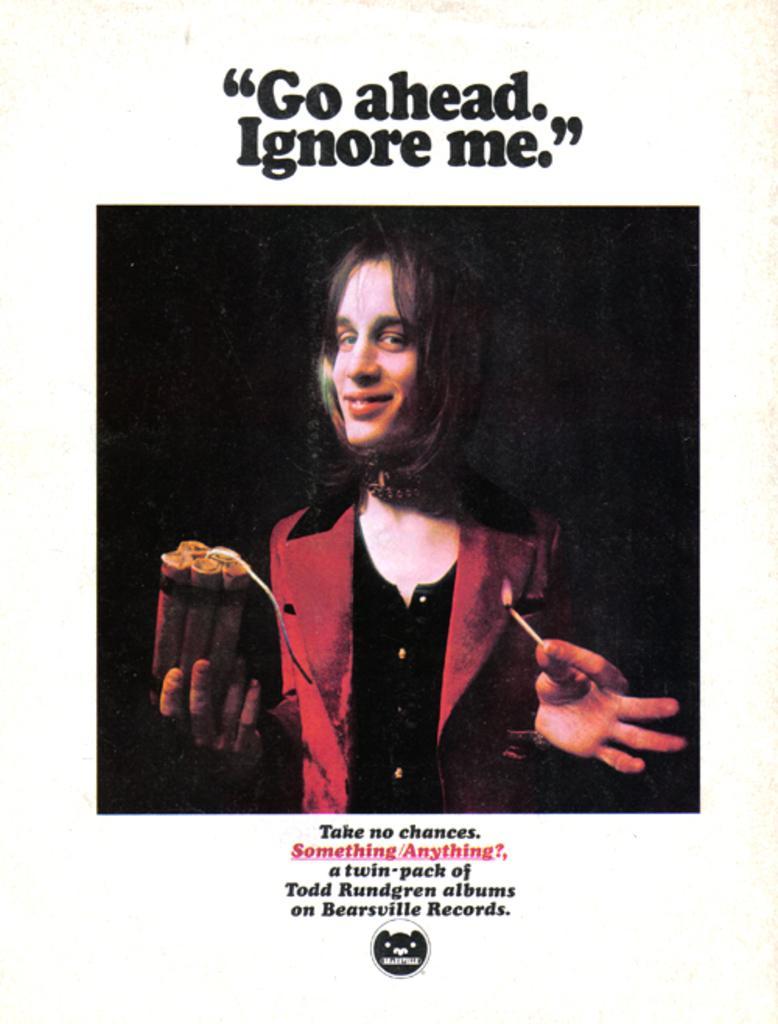Can you describe this image briefly? In the center of the image we can see a person holding a bomb. At the bottom and top we can see a text. 